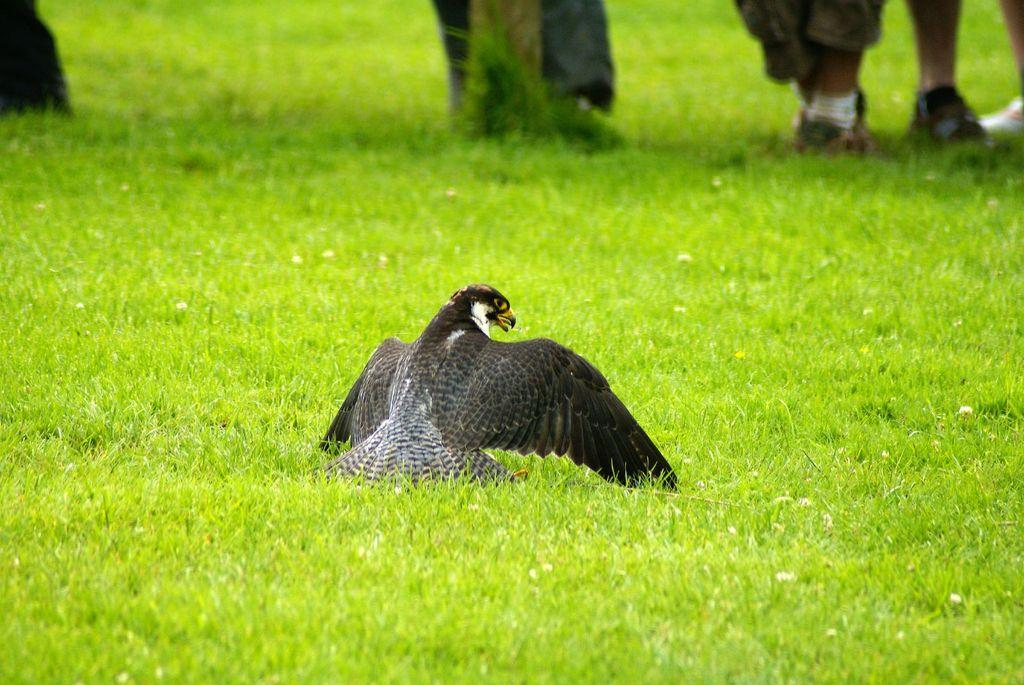What is the main subject in the center of the picture? There is an eagle in the center of the picture. What type of vegetation can be seen in the image? There is grass in the image. What can be seen at the top of the image? There are legs of persons visible at the top of the image. What object is present in the image besides the eagle and grass? There is a pole in the image. What type of skirt is the eagle wearing in the image? The eagle is a bird and does not wear clothing, so there is no skirt present in the image. 